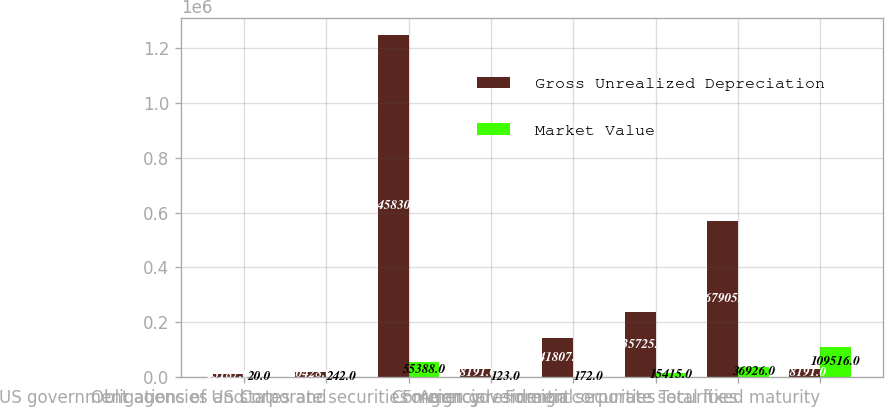Convert chart to OTSL. <chart><loc_0><loc_0><loc_500><loc_500><stacked_bar_chart><ecel><fcel>US government agencies and<fcel>Obligations of US states and<fcel>Corporate securities<fcel>Commercial<fcel>Agency residential<fcel>Foreign government securities<fcel>Foreign corporate securities<fcel>Total fixed maturity<nl><fcel>Gross Unrealized Depreciation<fcel>13187<fcel>20428<fcel>1.24583e+06<fcel>28191<fcel>141807<fcel>235725<fcel>567905<fcel>28191<nl><fcel>Market Value<fcel>20<fcel>242<fcel>55388<fcel>123<fcel>172<fcel>15415<fcel>36926<fcel>109516<nl></chart> 